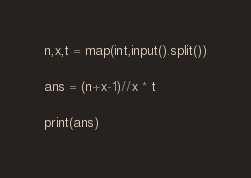Convert code to text. <code><loc_0><loc_0><loc_500><loc_500><_Python_>n,x,t = map(int,input().split())

ans = (n+x-1)//x * t

print(ans)</code> 